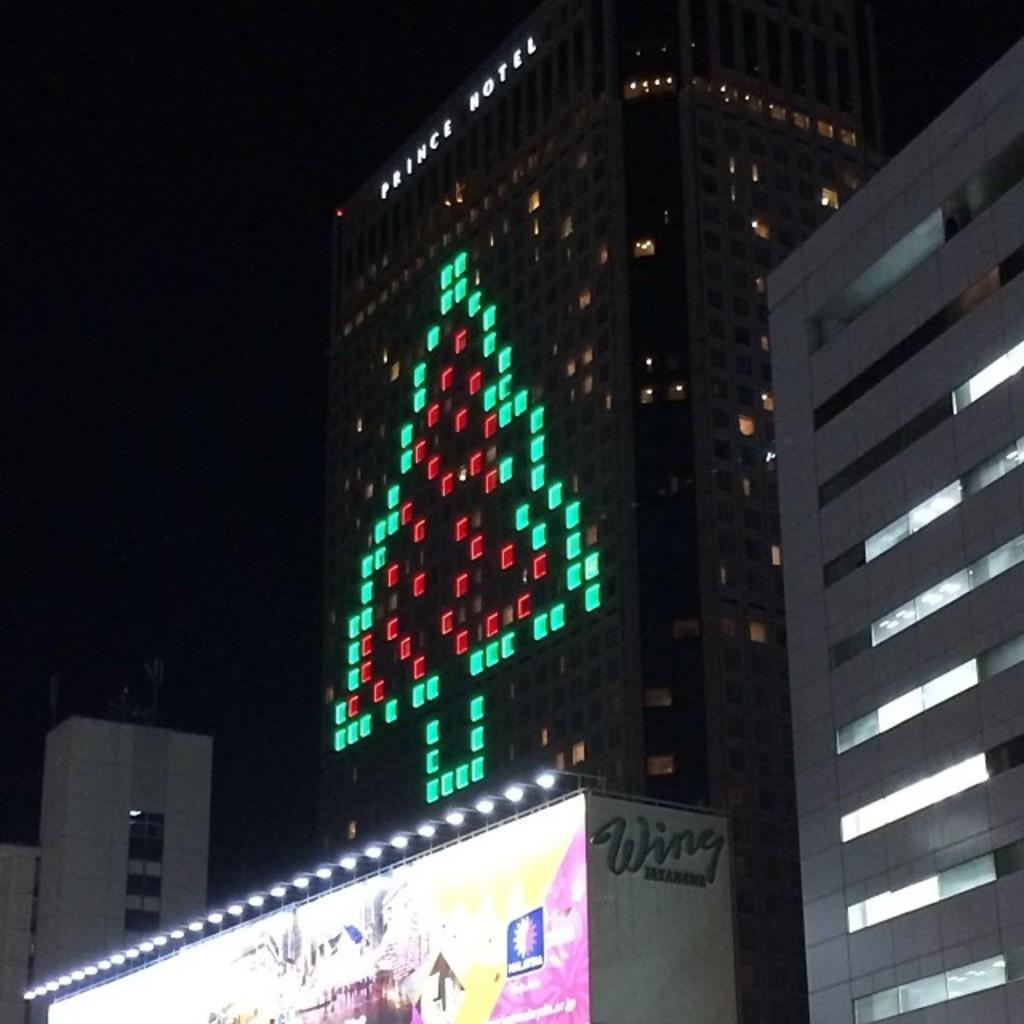What type of structures can be seen in the image? There are buildings in the image. What can be observed illuminating the scene in the image? There are lights visible in the image. What is the interest rate on the loan associated with the buildings in the image? There is no information about loans or interest rates in the image, as it only shows buildings and lights. 